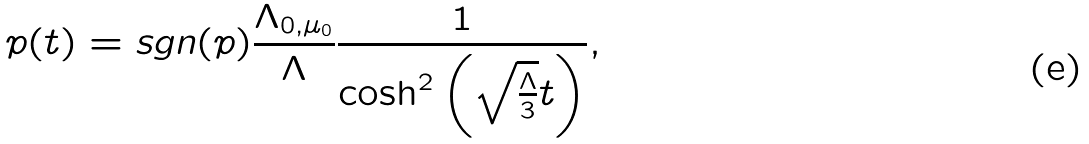<formula> <loc_0><loc_0><loc_500><loc_500>p ( t ) = \text {sgn} ( p ) \frac { \Lambda _ { 0 , \mu _ { 0 } } } { \Lambda } \frac { 1 } { \cosh ^ { 2 } { \left ( \sqrt { \frac { \Lambda } { 3 } } t \right ) } } ,</formula> 